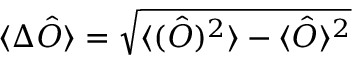Convert formula to latex. <formula><loc_0><loc_0><loc_500><loc_500>\langle \Delta \hat { O } \rangle = \sqrt { \langle ( \hat { O } ) ^ { 2 } \rangle - \langle \hat { O } \rangle ^ { 2 } }</formula> 